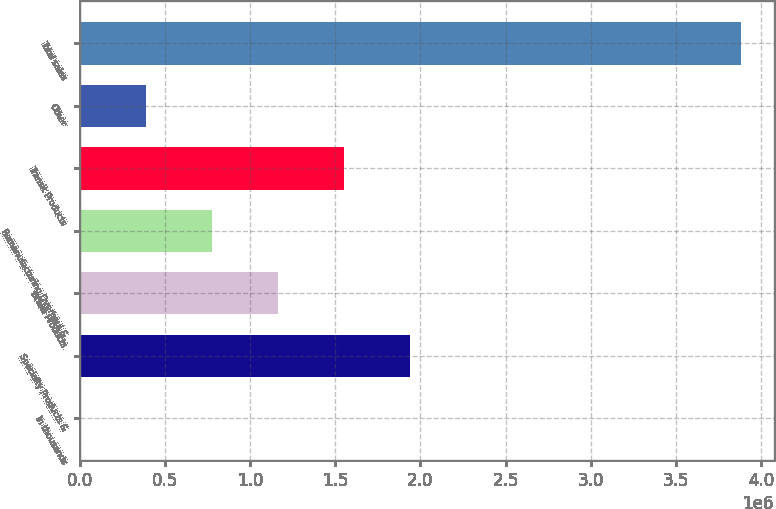Convert chart. <chart><loc_0><loc_0><loc_500><loc_500><bar_chart><fcel>In thousands<fcel>Specialty Products &<fcel>Brake Products<fcel>Remanufacturing Overhaul &<fcel>Transit Products<fcel>Other<fcel>Total sales<nl><fcel>2017<fcel>1.94189e+06<fcel>1.16594e+06<fcel>777965<fcel>1.55391e+06<fcel>389991<fcel>3.88176e+06<nl></chart> 